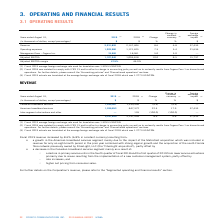According to Cogeco's financial document, What was the average foreign exchange rate of fiscal 2018? According to the financial document, 1.2773 USD/CDN. The relevant text states: "ge foreign exchange rate of fiscal 2018 which was 1.2773 USD/CDN...." Also, What caused the decrease in the Canadian broadband services segment? a decline in primary service units in the fourth quarter of fiscal 2018 and the first quarter of 2019 from lower service activations primarily due to issues resulting from the implementation of a new customer management system; partly offset by ◦ rate increases; and ◦ higher net pricing from consumer sales.. The document states: "◦ a decline in primary service units in the fourth quarter of fiscal 2018 and the first quarter of 2019 from lower service activations primarily due t..." Also, What was the Canadian broadband services in 2019? According to the financial document, 1,294,967 (in millions). The relevant text states: "Canadian broadband services 1,294,967 1,299,906 (0.4) (0.4) —..." Also, can you calculate: What is the increase / (decrease) in Canadian broadband services from 2018 to 2019? Based on the calculation: 1,294,967 - 1,299,906, the result is -4939 (in millions). This is based on the information: "Canadian broadband services 1,294,967 1,299,906 (0.4) (0.4) — Canadian broadband services 1,294,967 1,299,906 (0.4) (0.4) —..." The key data points involved are: 1,294,967, 1,299,906. Also, can you calculate: What was the average American broadband services between 2018 and 2019? To answer this question, I need to perform calculations using the financial data. The calculation is: (1,036,853 + 847,372) / 2, which equals 942112.5 (in millions). This is based on the information: "American broadband services 1,036,853 847,372 22.4 17.9 37,433 American broadband services 1,036,853 847,372 22.4 17.9 37,433..." The key data points involved are: 1,036,853, 847,372. Also, can you calculate: What was the increase / (decrease) of Inter-segment eliminations and other from 2018 to 2019? Based on the calculation: 0 - 126, the result is -126 (in millions). This is based on the information: "Years ended August 31, 2019 (1) 2018 (2) Change Inter-segment eliminations and other — 126 (100.0) (100.0) —..." The key data points involved are: 0. 